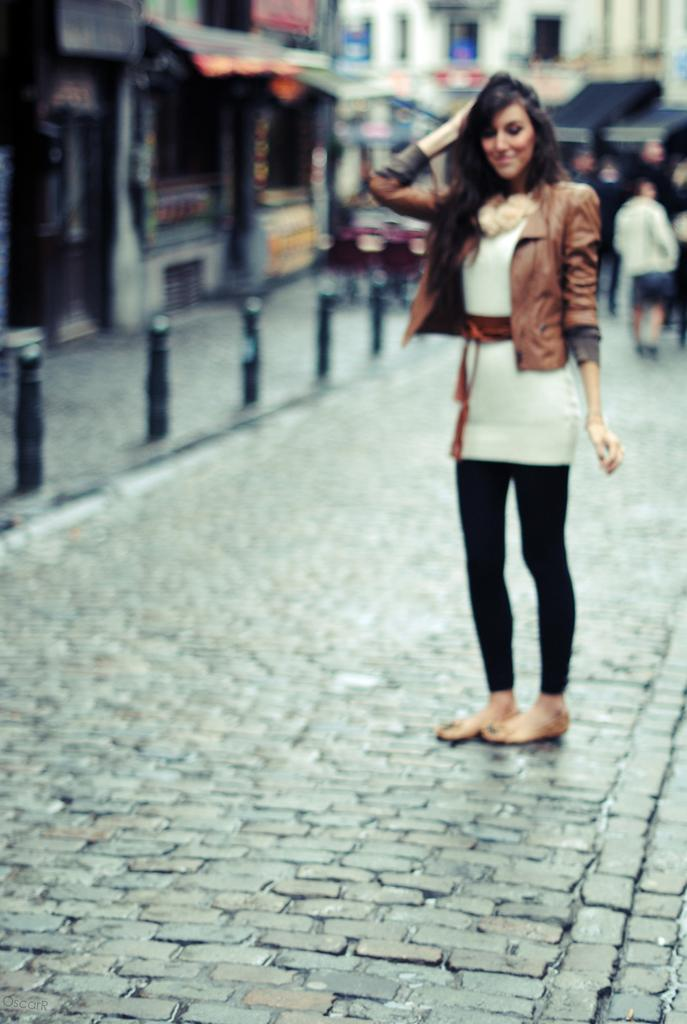What is the main subject of the image? The main subject of the image is a woman standing. What is the woman standing on? There is a surface on which the woman is standing. What can be seen in the background of the image? There are buildings visible in the background of the image. Are there any other people visible in the image? Yes, there is at least one person visible in the background of the image. What type of theory can be seen being discussed by the pigs on the train in the image? There are no pigs or trains present in the image, so it is not possible to determine what theory might be discussed. 